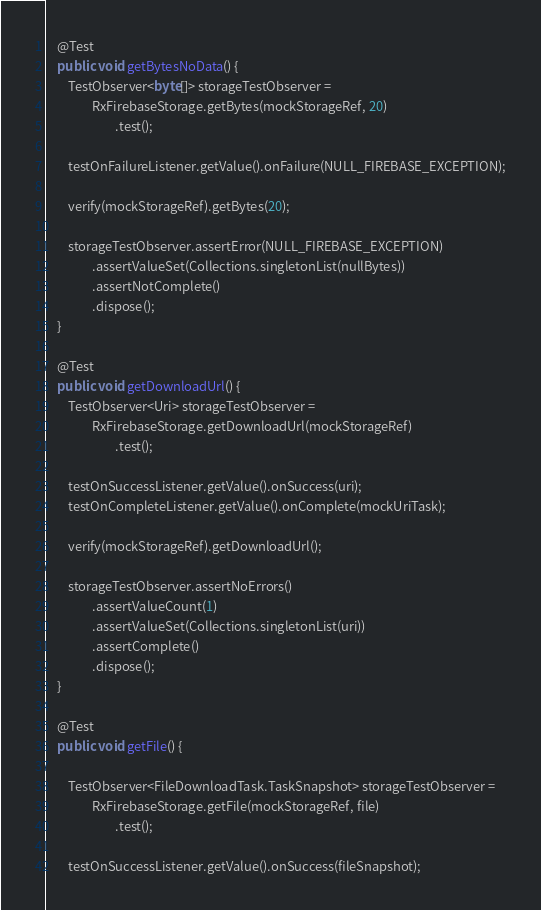<code> <loc_0><loc_0><loc_500><loc_500><_Java_>    @Test
    public void getBytesNoData() {
        TestObserver<byte[]> storageTestObserver =
                RxFirebaseStorage.getBytes(mockStorageRef, 20)
                        .test();

        testOnFailureListener.getValue().onFailure(NULL_FIREBASE_EXCEPTION);

        verify(mockStorageRef).getBytes(20);

        storageTestObserver.assertError(NULL_FIREBASE_EXCEPTION)
                .assertValueSet(Collections.singletonList(nullBytes))
                .assertNotComplete()
                .dispose();
    }

    @Test
    public void getDownloadUrl() {
        TestObserver<Uri> storageTestObserver =
                RxFirebaseStorage.getDownloadUrl(mockStorageRef)
                        .test();

        testOnSuccessListener.getValue().onSuccess(uri);
        testOnCompleteListener.getValue().onComplete(mockUriTask);

        verify(mockStorageRef).getDownloadUrl();

        storageTestObserver.assertNoErrors()
                .assertValueCount(1)
                .assertValueSet(Collections.singletonList(uri))
                .assertComplete()
                .dispose();
    }

    @Test
    public void getFile() {

        TestObserver<FileDownloadTask.TaskSnapshot> storageTestObserver =
                RxFirebaseStorage.getFile(mockStorageRef, file)
                        .test();

        testOnSuccessListener.getValue().onSuccess(fileSnapshot);
</code> 